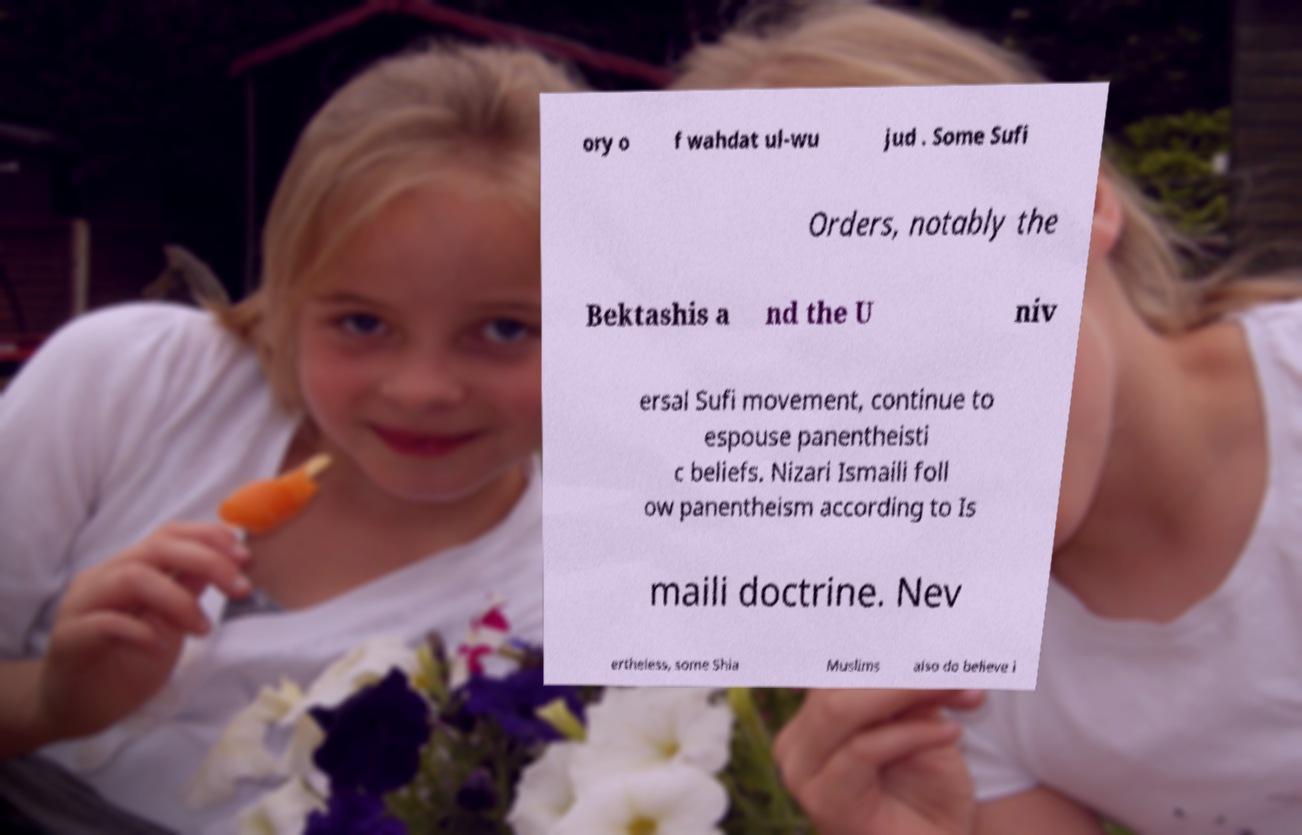Can you accurately transcribe the text from the provided image for me? ory o f wahdat ul-wu jud . Some Sufi Orders, notably the Bektashis a nd the U niv ersal Sufi movement, continue to espouse panentheisti c beliefs. Nizari Ismaili foll ow panentheism according to Is maili doctrine. Nev ertheless, some Shia Muslims also do believe i 